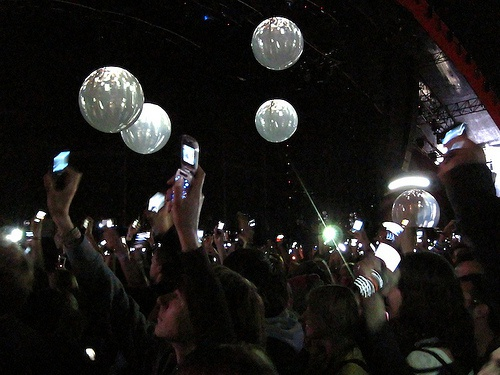Describe the objects in this image and their specific colors. I can see people in black, maroon, and gray tones, people in black, gray, and maroon tones, people in black, maroon, and gray tones, people in black and gray tones, and people in black and maroon tones in this image. 